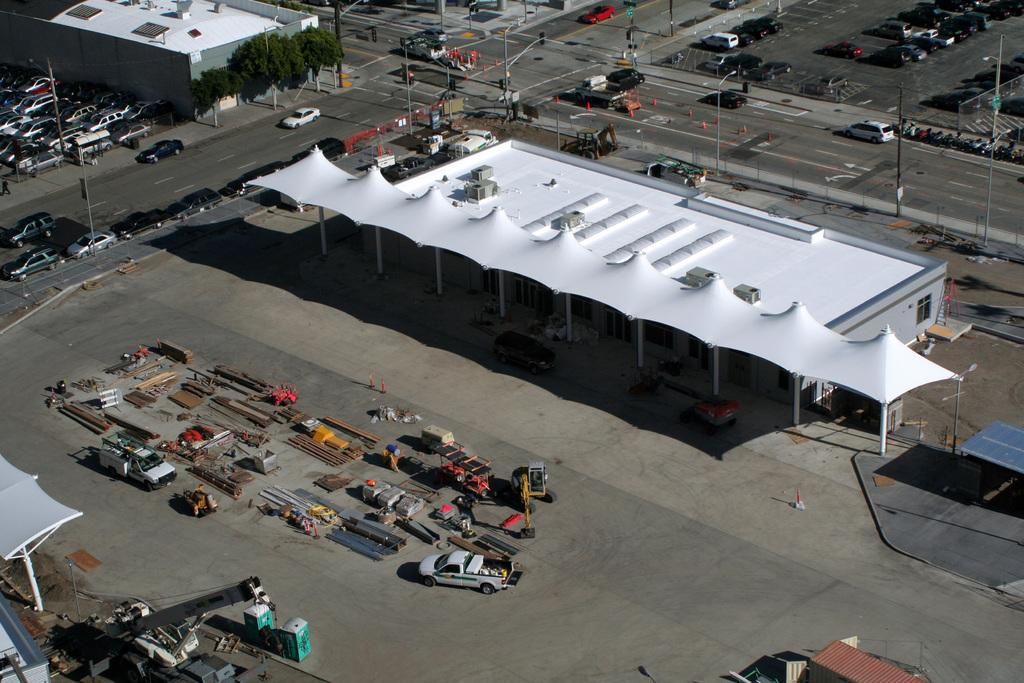What is the perspective of the image? The image is taken from a top view. What type of structures can be seen in the image? There are buildings in the image. What natural elements are present in the image? There are trees in the image. What type of vehicles can be seen in the image? There are cars in the image. What type of coverings are present in the image? There are canopies in the image. What type of construction equipment is present in the image? There is a crane in the image. What type of transportation infrastructure is present in the image? There are roads in the image. What type of lighting is present in the image? There are street lights in the image. What type of vertical structures are present in the image? There are poles in the image. What other objects can be seen in the image? There are other objects in the image. What type of sink can be seen in the image? There is no sink present in the image. What observation can be made about the need for more trees in the image? The image does not provide any information about the need for more trees; it only shows the existing trees. 